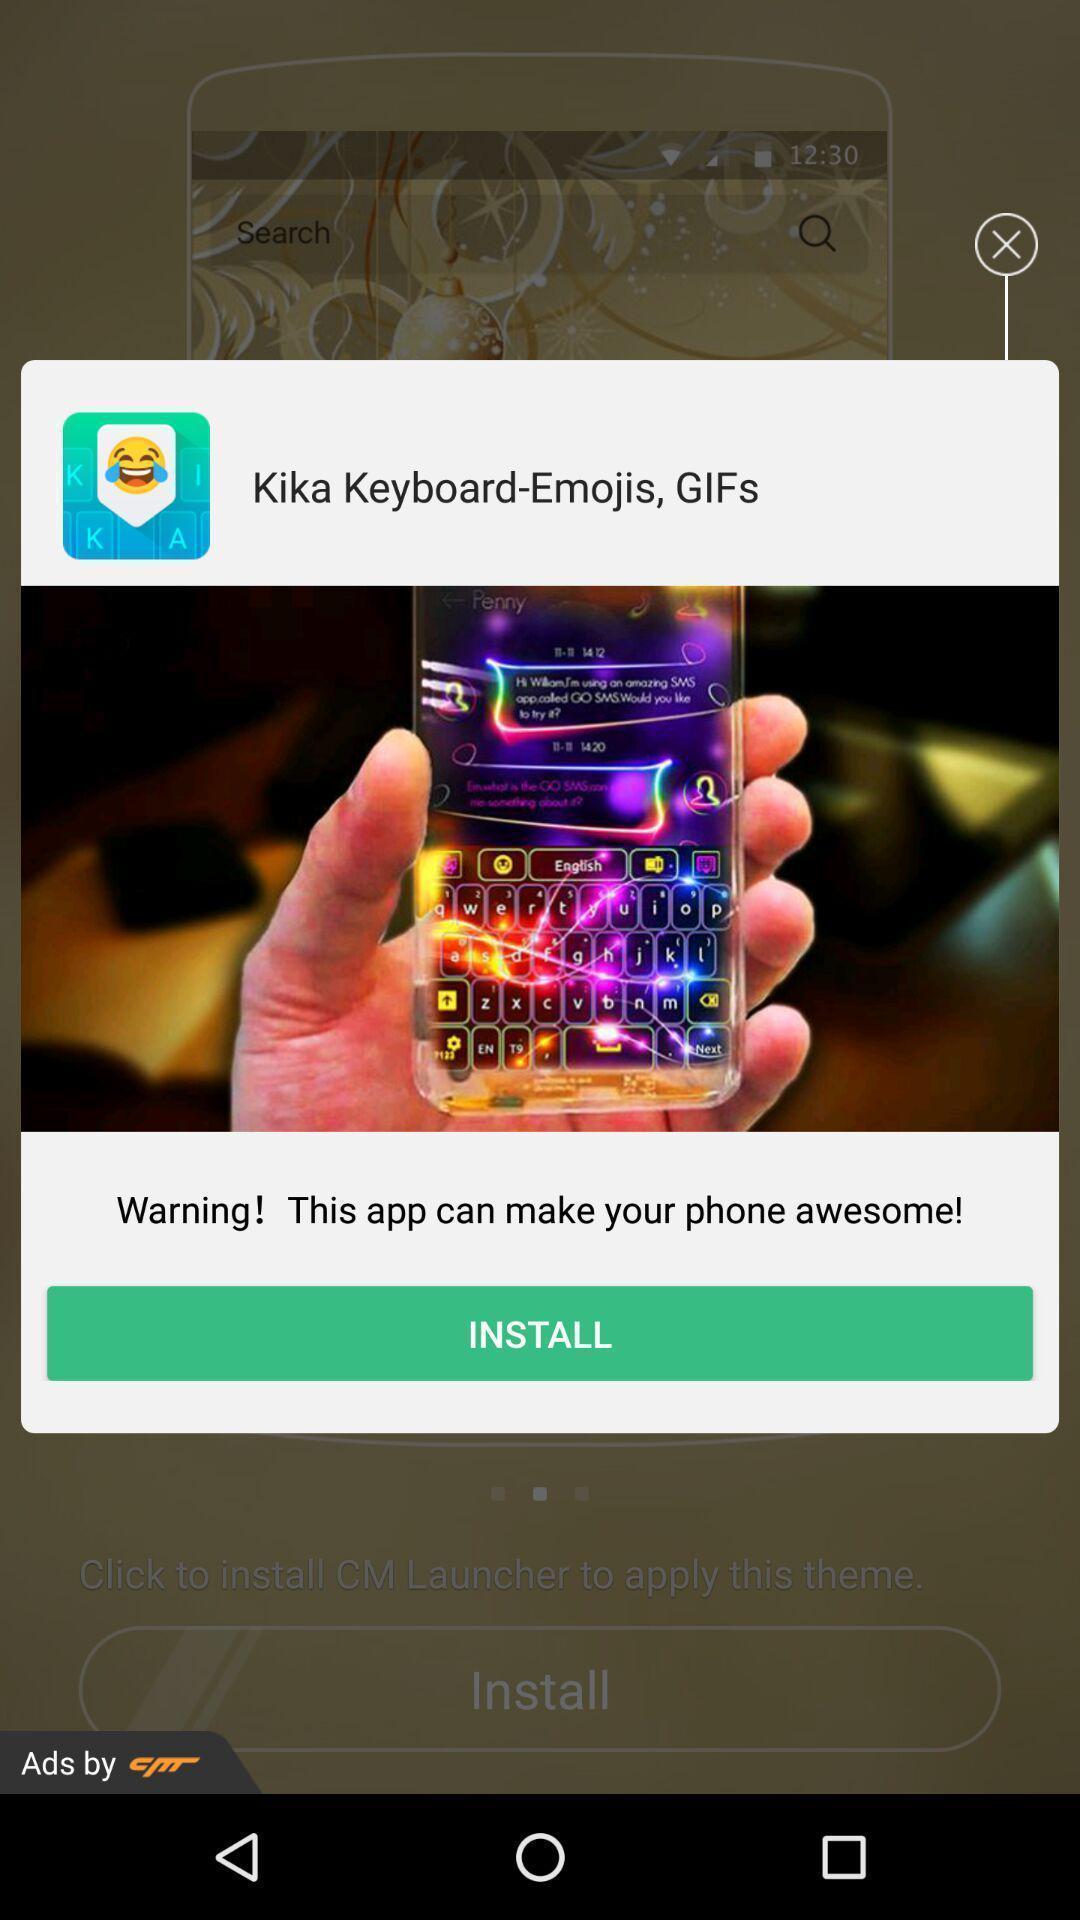Describe this image in words. Pop-up showing recommendation for installing app. 